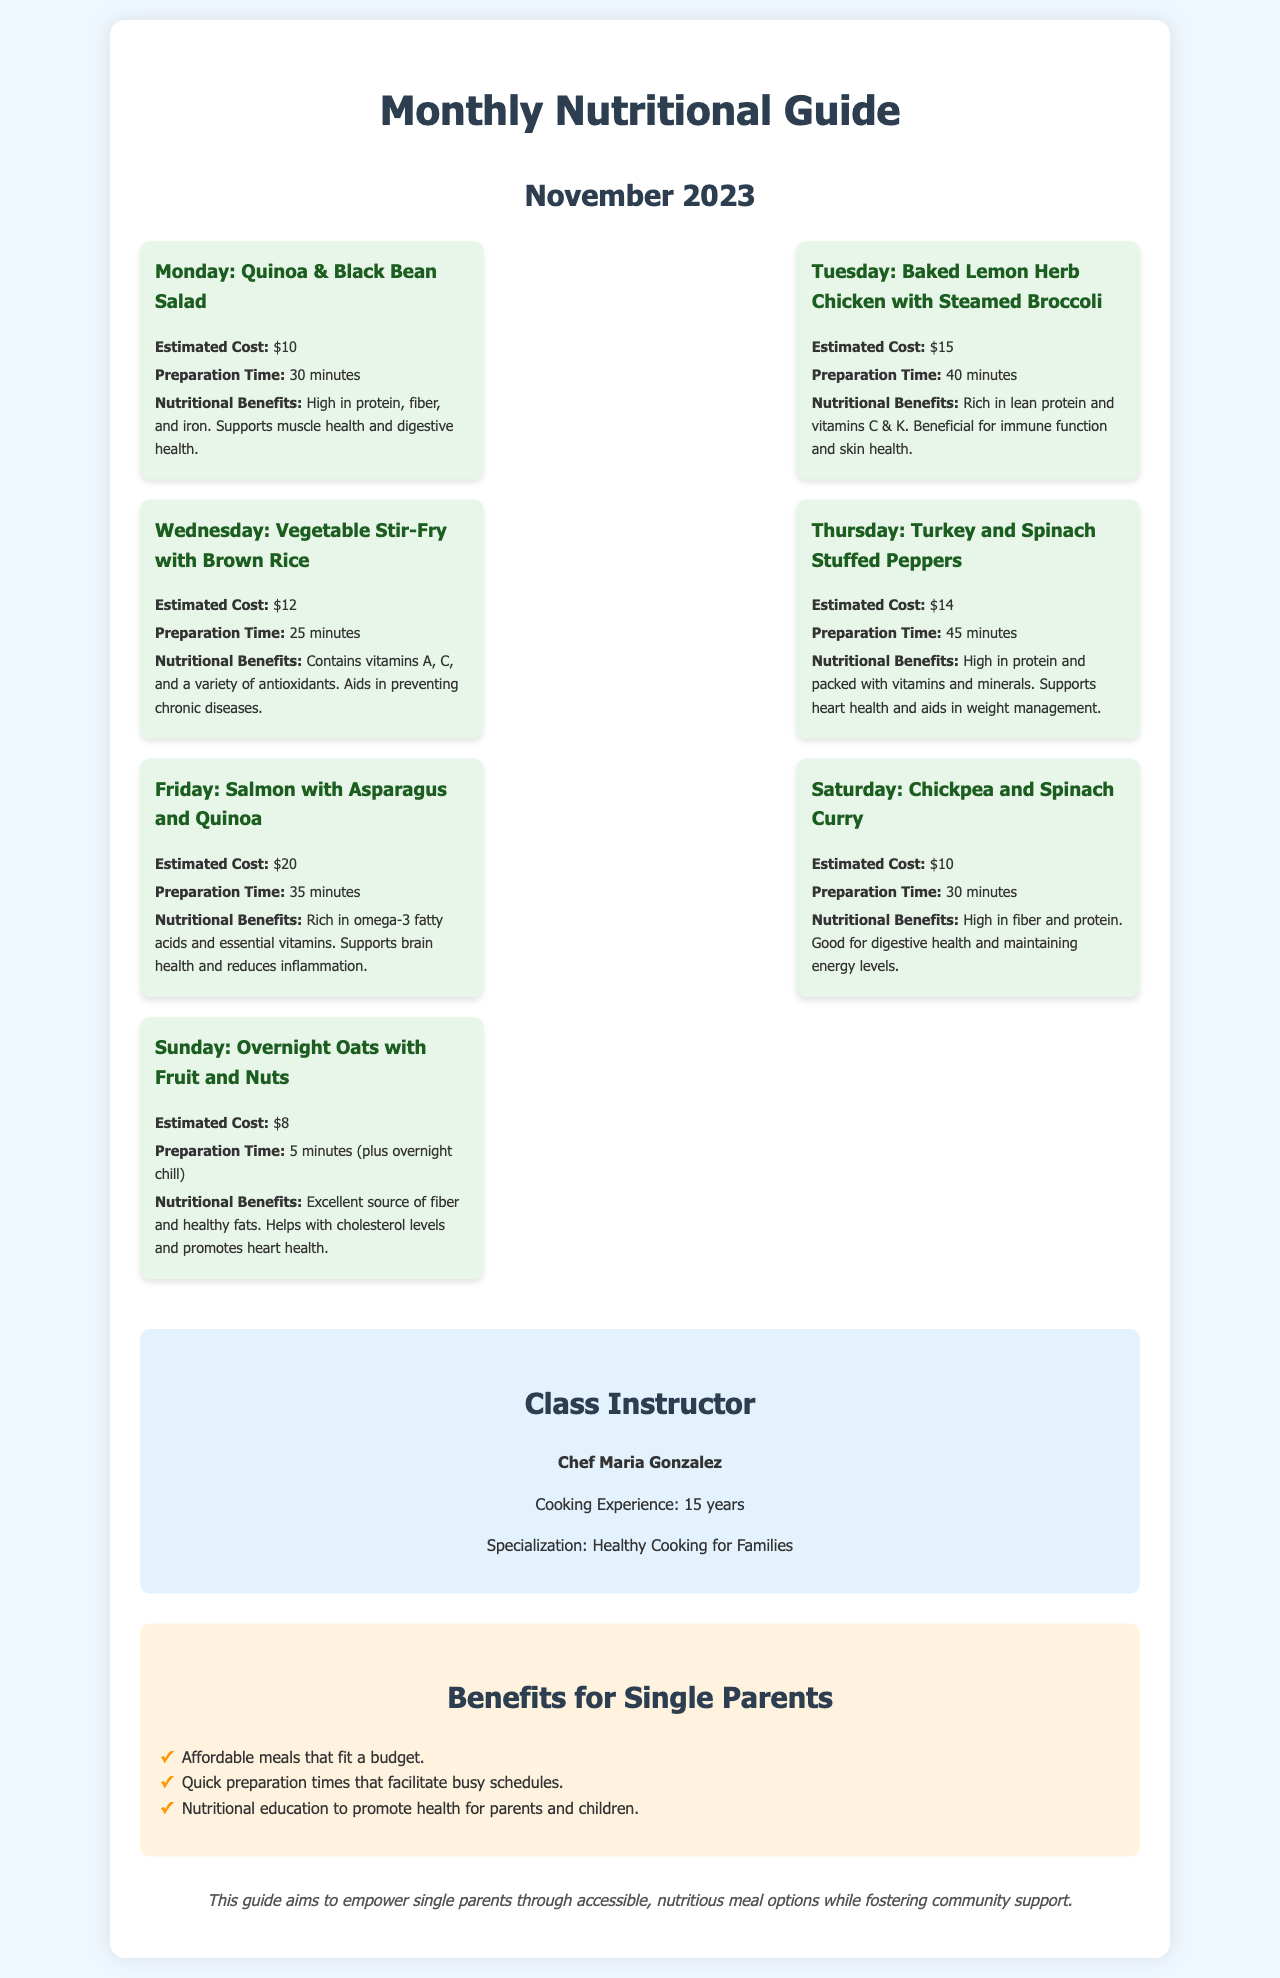What is the estimated cost of the Quinoa & Black Bean Salad? The estimated cost is stated clearly in the document under the meal plan for Monday.
Answer: $10 How long does it take to prepare the Baked Lemon Herb Chicken with Steamed Broccoli? The preparation time is listed for the recipe on Tuesday in the document.
Answer: 40 minutes What nutritional benefit is highlighted for the Vegetable Stir-Fry with Brown Rice? This benefit is mentioned in the nutritional benefits section of the Wednesday meal plan.
Answer: Contains vitamins A, C, and a variety of antioxidants Who is the class instructor? The document specifically names the instructor in the respective section.
Answer: Chef Maria Gonzalez What day features the Salmon with Asparagus and Quinoa? The document provides a clear association of meals to their respective days.
Answer: Friday Which meal has the least estimated cost? By comparing the estimated costs presented in the meal plans, we can find the lowest one.
Answer: $8 What is a benefit for single parents mentioned in the document? The document lists various benefits in a dedicated section for single parents.
Answer: Affordable meals that fit a budget How many years of cooking experience does Chef Maria Gonzalez have? The document provides this specific information about the instructor.
Answer: 15 years 